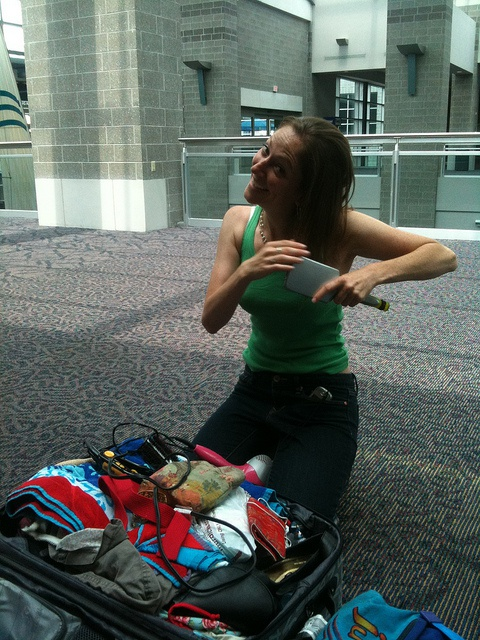Describe the objects in this image and their specific colors. I can see people in lightgray, black, gray, and tan tones, suitcase in lightgray, black, gray, brown, and maroon tones, backpack in lightgray, blue, teal, navy, and black tones, and handbag in lightgray, lightblue, black, and gray tones in this image. 